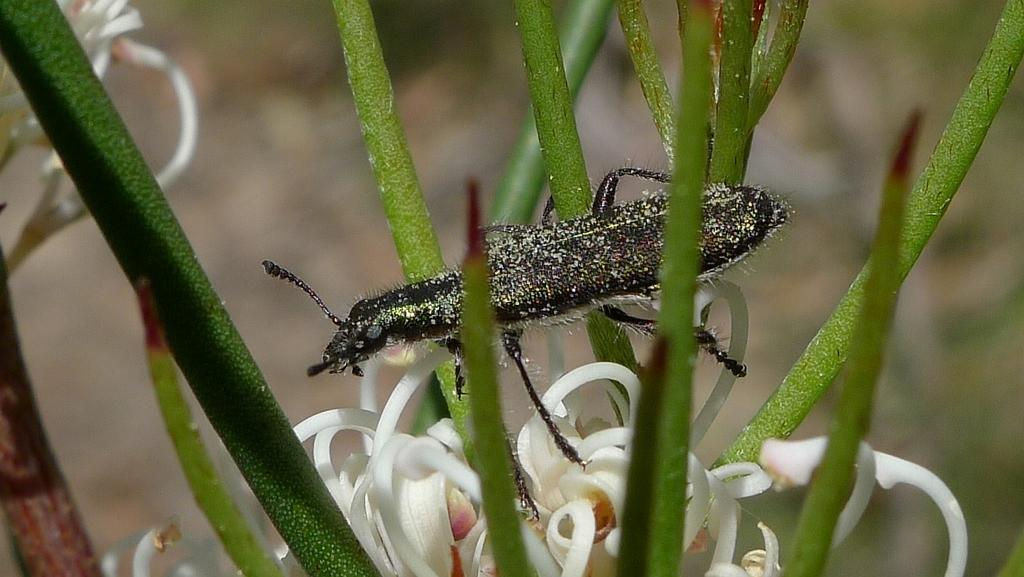What is present on the plant in the image? There is an insect on a plant in the image. Can you describe the background of the image? The background of the image is blurred. What type of boundary can be seen in the image? There is no boundary present in the image; it features an insect on a plant with a blurred background. Can you tell me how many goats are visible in the image? There are no goats present in the image. 